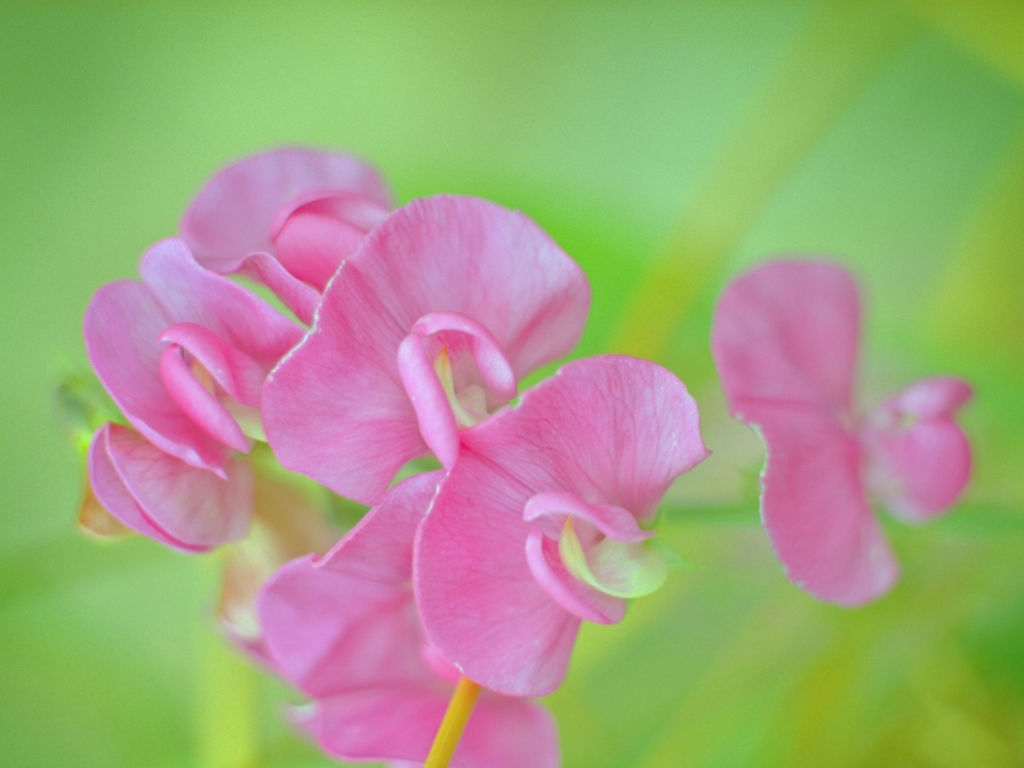Could you describe the mood or atmosphere conveyed by this image? The image emanates a serene and gentle mood. The soft focus and bright, natural lighting contribute to a peaceful and inviting atmosphere, where the viewer might feel a sense of relaxation and contemplation. What might be the best setting to display this kind of image? This type of image would be well-suited for spaces meant for relaxation or meditation, such as a spa, a quiet reading nook, or a bedroom. Its soothing colors and subject matter are ideal for creating a tranquil environment. 